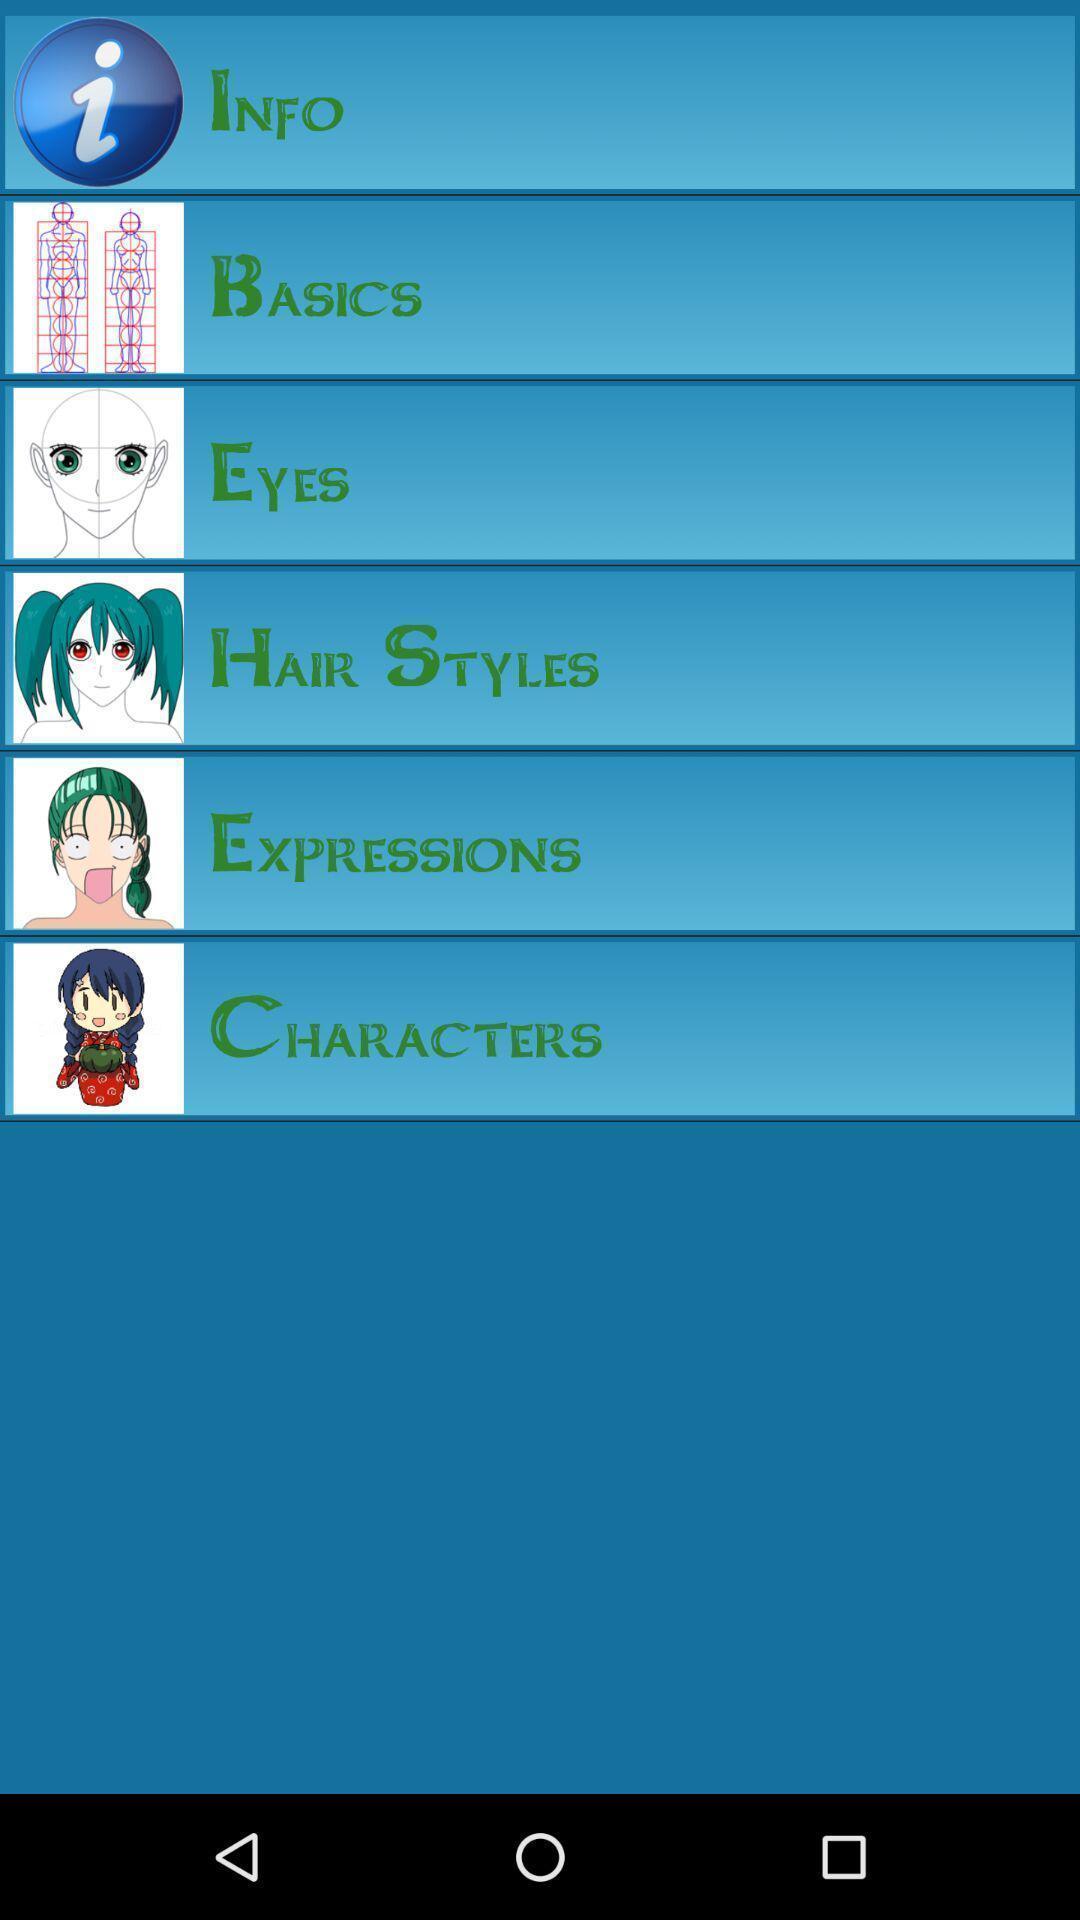What is the overall content of this screenshot? Page showing info. 